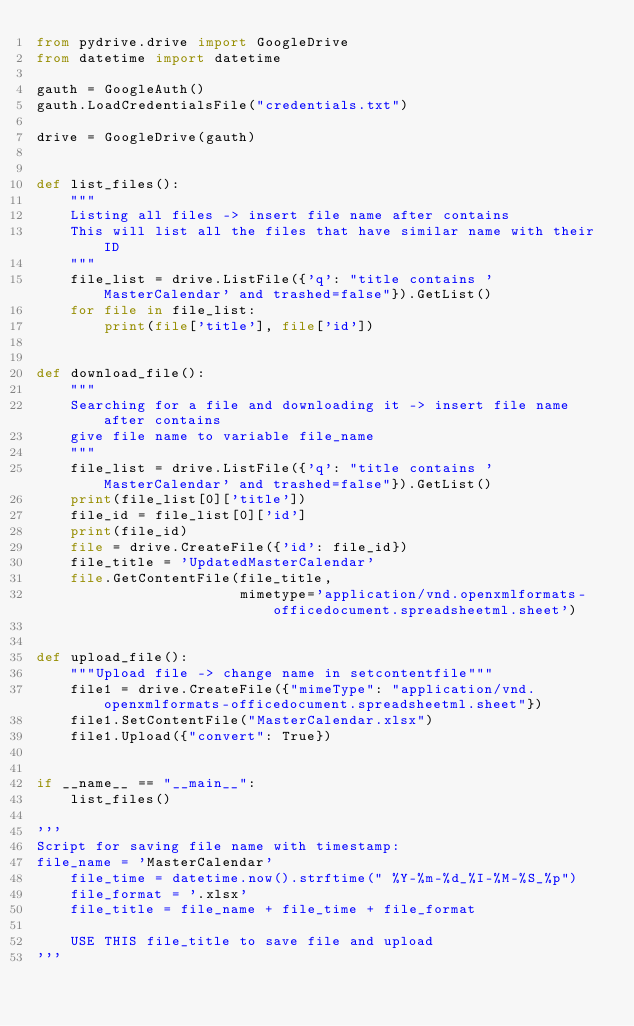Convert code to text. <code><loc_0><loc_0><loc_500><loc_500><_Python_>from pydrive.drive import GoogleDrive
from datetime import datetime

gauth = GoogleAuth()
gauth.LoadCredentialsFile("credentials.txt")

drive = GoogleDrive(gauth)


def list_files():
    """
    Listing all files -> insert file name after contains
    This will list all the files that have similar name with their ID
    """
    file_list = drive.ListFile({'q': "title contains 'MasterCalendar' and trashed=false"}).GetList()
    for file in file_list:
        print(file['title'], file['id'])


def download_file():
    """
    Searching for a file and downloading it -> insert file name after contains
    give file name to variable file_name
    """
    file_list = drive.ListFile({'q': "title contains 'MasterCalendar' and trashed=false"}).GetList()
    print(file_list[0]['title'])
    file_id = file_list[0]['id']
    print(file_id)
    file = drive.CreateFile({'id': file_id})
    file_title = 'UpdatedMasterCalendar'
    file.GetContentFile(file_title,
                        mimetype='application/vnd.openxmlformats-officedocument.spreadsheetml.sheet')


def upload_file():
    """Upload file -> change name in setcontentfile"""
    file1 = drive.CreateFile({"mimeType": "application/vnd.openxmlformats-officedocument.spreadsheetml.sheet"})
    file1.SetContentFile("MasterCalendar.xlsx")
    file1.Upload({"convert": True})


if __name__ == "__main__":
    list_files()

'''
Script for saving file name with timestamp:
file_name = 'MasterCalendar'
    file_time = datetime.now().strftime(" %Y-%m-%d_%I-%M-%S_%p")
    file_format = '.xlsx'
    file_title = file_name + file_time + file_format
    
    USE THIS file_title to save file and upload
'''</code> 